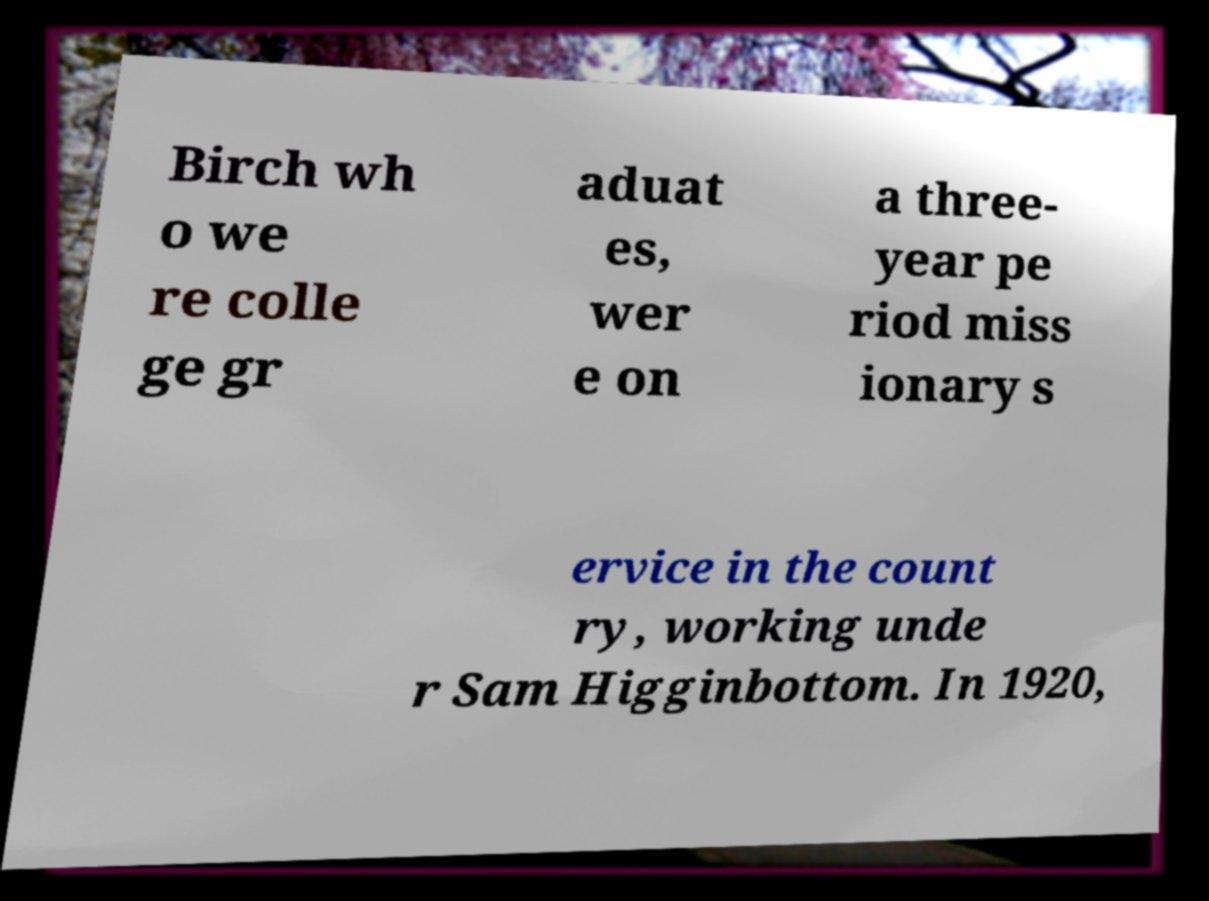I need the written content from this picture converted into text. Can you do that? Birch wh o we re colle ge gr aduat es, wer e on a three- year pe riod miss ionary s ervice in the count ry, working unde r Sam Higginbottom. In 1920, 